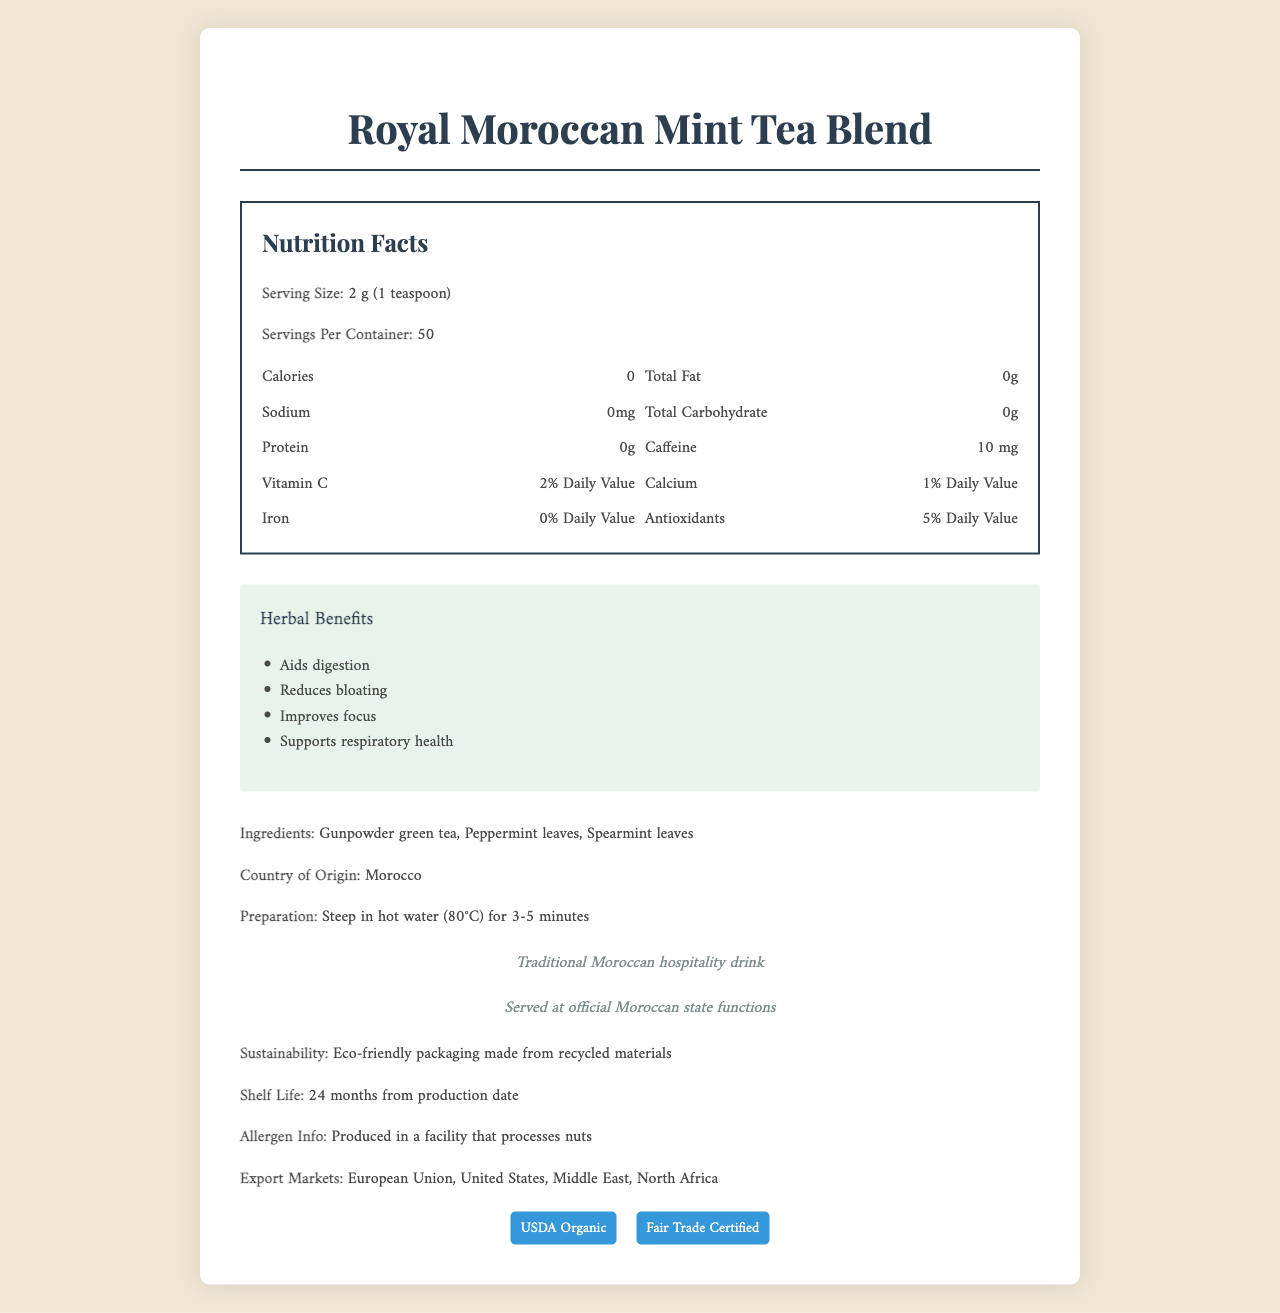What is the serving size of the Royal Moroccan Mint Tea Blend? The serving size is clearly stated as 2 g (1 teaspoon) in the nutrition facts section.
Answer: 2 g (1 teaspoon) How many servings are there per container? The servings per container are listed as 50 in the nutrition facts section.
Answer: 50 How much caffeine does each serving contain? The amount of caffeine per serving is specified as 10 mg in the nutrition facts section.
Answer: 10 mg What are the main ingredients in the Royal Moroccan Mint Tea Blend? The ingredients list includes Gunpowder green tea, Peppermint leaves, and Spearmint leaves.
Answer: Gunpowder green tea, Peppermint leaves, Spearmint leaves What is the primary cultural significance of the Royal Moroccan Mint Tea Blend? The document mentions that the tea is a traditional Moroccan hospitality drink.
Answer: Traditional Moroccan hospitality drink Which of the following health benefits is NOT associated with the Royal Moroccan Mint Tea Blend?
A. Aids digestion
B. Enhances sleep
C. Improves focus
D. Supports respiratory health The herbal benefits listed in the document include aiding digestion, improving focus, and supporting respiratory health, but not enhancing sleep.
Answer: B How should the Royal Moroccan Mint Tea Blend be prepared? The preparation instructions specify steeping the tea in hot water (80°C) for 3-5 minutes.
Answer: Steep in hot water (80°C) for 3-5 minutes Is the tea blend USDA Organic certified? The document includes a certification badge indicating that the product is USDA Organic certified.
Answer: Yes Summarize the main ideas of the document. The document provides detailed information about the Royal Moroccan Mint Tea Blend's nutrition facts, ingredients, herbal benefits, certifications, and cultural significance. It highlights caffeine content and eco-friendly packaging while offering preparation guidelines.
Answer: The Royal Moroccan Mint Tea Blend is a traditional Moroccan drink known for various health benefits such as aiding digestion and improving focus. It contains Gunpowder green tea, Peppermint, and Spearmint leaves and has a serving size of 2 g with 50 servings per container. The tea is caffeine content is 10 mg per serving. It is USDA Organic and Fair Trade Certified, prepared by steeping in hot water for 3-5 minutes, and packed using eco-friendly materials. The tea is served at official state functions and has a cultural significance in Moroccan hospitality. Which countries are listed as export markets for this product?
I. European Union
II. United States
III. Russia
IV. Middle East The document lists European Union, United States, Middle East, and North Africa as export markets. Russia is not listed as an export market.
Answer: III What is the shelf life of the Royal Moroccan Mint Tea Blend? The shelf life is mentioned as 24 months from the production date.
Answer: 24 months from production date What allergens might one need to be aware of when consuming this product? The allergen information states that the product is produced in a facility that processes nuts.
Answer: Produced in a facility that processes nuts What is the Daily Value percentage of antioxidants per serving? The percentage Daily Value of antioxidants per serving is listed as 5% in the nutrition facts section.
Answer: 5% Does the product have any iron content? The nutrition facts section lists iron content as 0% Daily Value, indicating no iron content.
Answer: No Can you tell the specific recycled materials used in the packaging? The document mentions that the packaging is eco-friendly and made from recycled materials, but it does not specify what those materials are.
Answer: Not enough information 